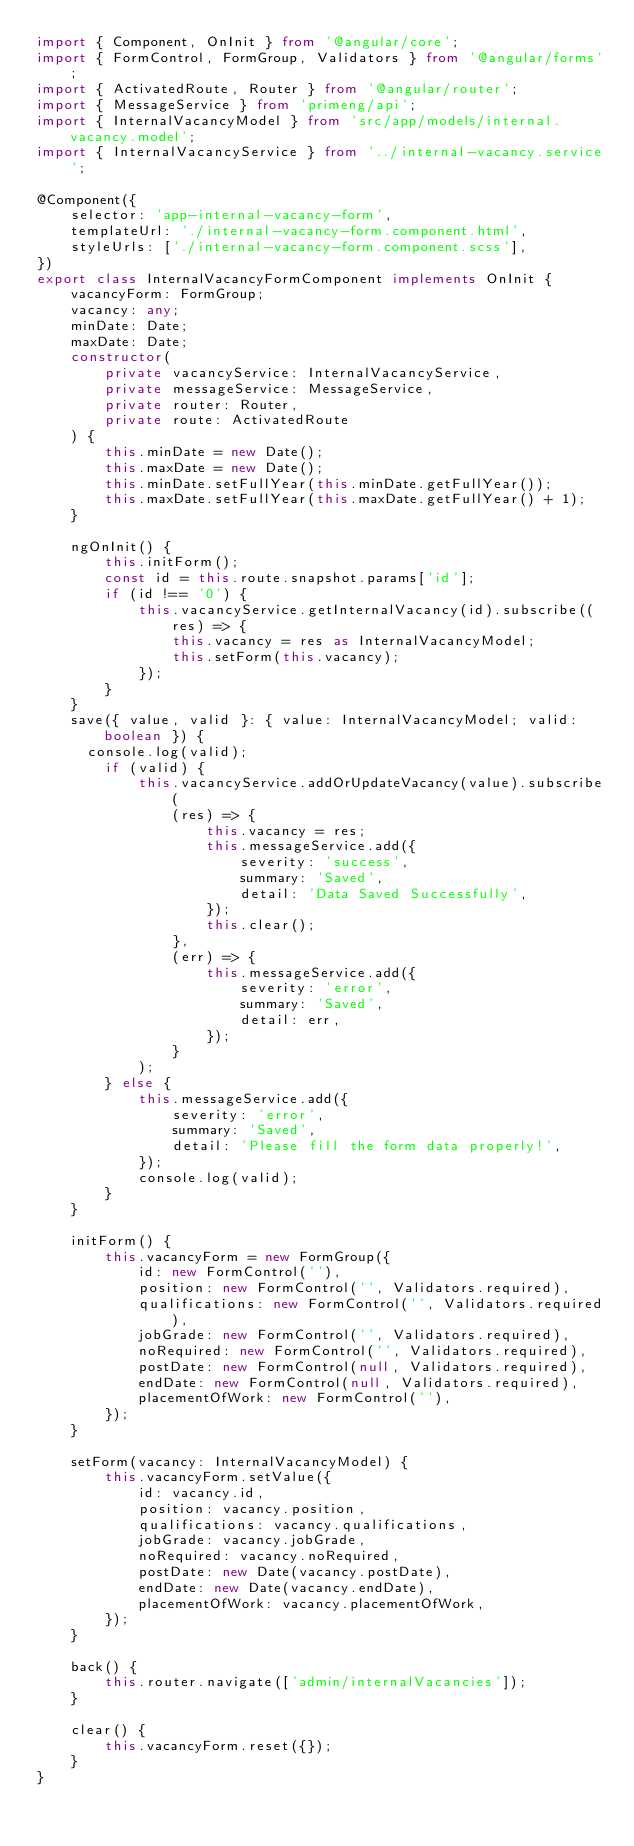<code> <loc_0><loc_0><loc_500><loc_500><_TypeScript_>import { Component, OnInit } from '@angular/core';
import { FormControl, FormGroup, Validators } from '@angular/forms';
import { ActivatedRoute, Router } from '@angular/router';
import { MessageService } from 'primeng/api';
import { InternalVacancyModel } from 'src/app/models/internal.vacancy.model';
import { InternalVacancyService } from '../internal-vacancy.service';

@Component({
    selector: 'app-internal-vacancy-form',
    templateUrl: './internal-vacancy-form.component.html',
    styleUrls: ['./internal-vacancy-form.component.scss'],
})
export class InternalVacancyFormComponent implements OnInit {
    vacancyForm: FormGroup;
    vacancy: any;
    minDate: Date;
    maxDate: Date;
    constructor(
        private vacancyService: InternalVacancyService,
        private messageService: MessageService,
        private router: Router,
        private route: ActivatedRoute
    ) {
        this.minDate = new Date();
        this.maxDate = new Date();
        this.minDate.setFullYear(this.minDate.getFullYear());
        this.maxDate.setFullYear(this.maxDate.getFullYear() + 1);
    }

    ngOnInit() {
        this.initForm();
        const id = this.route.snapshot.params['id'];
        if (id !== '0') {
            this.vacancyService.getInternalVacancy(id).subscribe((res) => {
                this.vacancy = res as InternalVacancyModel;
                this.setForm(this.vacancy);
            });
        }
    }
    save({ value, valid }: { value: InternalVacancyModel; valid: boolean }) {
      console.log(valid);
        if (valid) {
            this.vacancyService.addOrUpdateVacancy(value).subscribe(
                (res) => {
                    this.vacancy = res;
                    this.messageService.add({
                        severity: 'success',
                        summary: 'Saved',
                        detail: 'Data Saved Successfully',
                    });
                    this.clear();
                },
                (err) => {
                    this.messageService.add({
                        severity: 'error',
                        summary: 'Saved',
                        detail: err,
                    });
                }
            );
        } else {
            this.messageService.add({
                severity: 'error',
                summary: 'Saved',
                detail: 'Please fill the form data properly!',
            });
            console.log(valid);
        }
    }

    initForm() {
        this.vacancyForm = new FormGroup({
            id: new FormControl(''),
            position: new FormControl('', Validators.required),
            qualifications: new FormControl('', Validators.required),
            jobGrade: new FormControl('', Validators.required),
            noRequired: new FormControl('', Validators.required),
            postDate: new FormControl(null, Validators.required),
            endDate: new FormControl(null, Validators.required),
            placementOfWork: new FormControl(''),
        });
    }

    setForm(vacancy: InternalVacancyModel) {
        this.vacancyForm.setValue({
            id: vacancy.id,
            position: vacancy.position,
            qualifications: vacancy.qualifications,
            jobGrade: vacancy.jobGrade,
            noRequired: vacancy.noRequired,
            postDate: new Date(vacancy.postDate),
            endDate: new Date(vacancy.endDate),
            placementOfWork: vacancy.placementOfWork,
        });
    }

    back() {
        this.router.navigate(['admin/internalVacancies']);
    }

    clear() {
        this.vacancyForm.reset({});
    }
}
</code> 